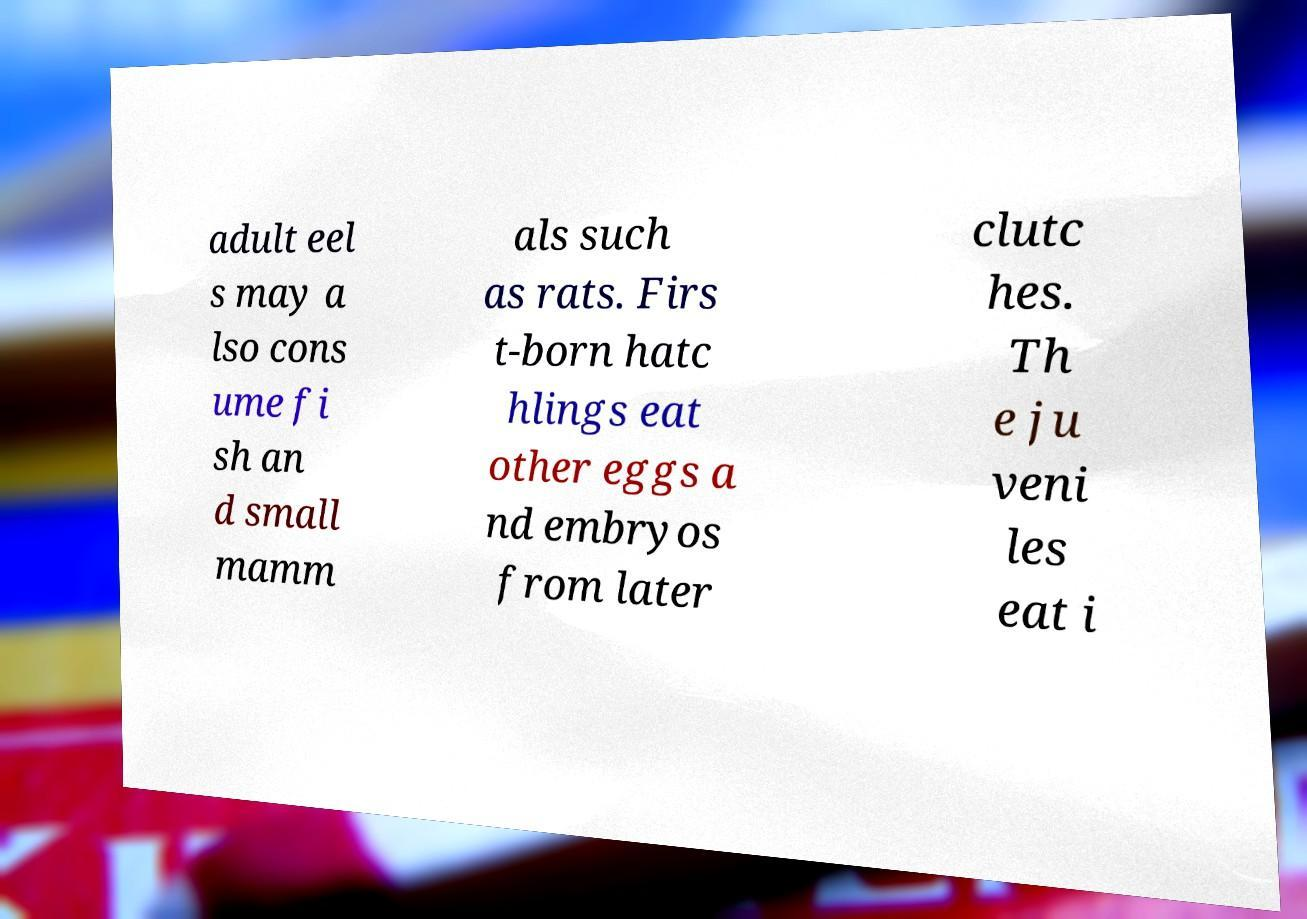Can you accurately transcribe the text from the provided image for me? adult eel s may a lso cons ume fi sh an d small mamm als such as rats. Firs t-born hatc hlings eat other eggs a nd embryos from later clutc hes. Th e ju veni les eat i 